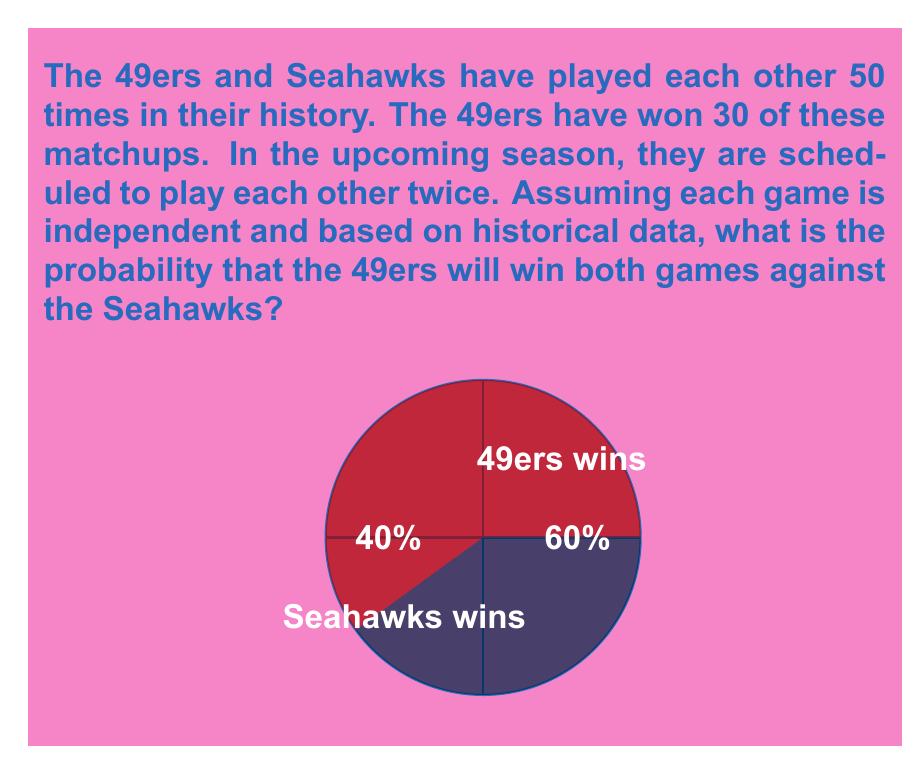Provide a solution to this math problem. Let's approach this step-by-step:

1) First, we need to calculate the probability of the 49ers winning a single game against the Seahawks based on historical data.

   $P(\text{49ers win}) = \frac{\text{Number of 49ers wins}}{\text{Total games}} = \frac{30}{50} = 0.6$ or $60\%$

2) Now, we need to find the probability of the 49ers winning both games. Since we're assuming the games are independent, we can use the multiplication rule of probability.

3) The probability of two independent events both occurring is the product of their individual probabilities:

   $P(A \text{ and } B) = P(A) \times P(B)$

4) In this case:
   
   $P(\text{49ers win both}) = P(\text{49ers win first}) \times P(\text{49ers win second})$
   
   $= 0.6 \times 0.6 = 0.36$

5) To convert to a percentage:

   $0.36 \times 100\% = 36\%$

Therefore, based on historical data, the probability that the 49ers will win both games against the Seahawks is 36%.
Answer: $36\%$ 